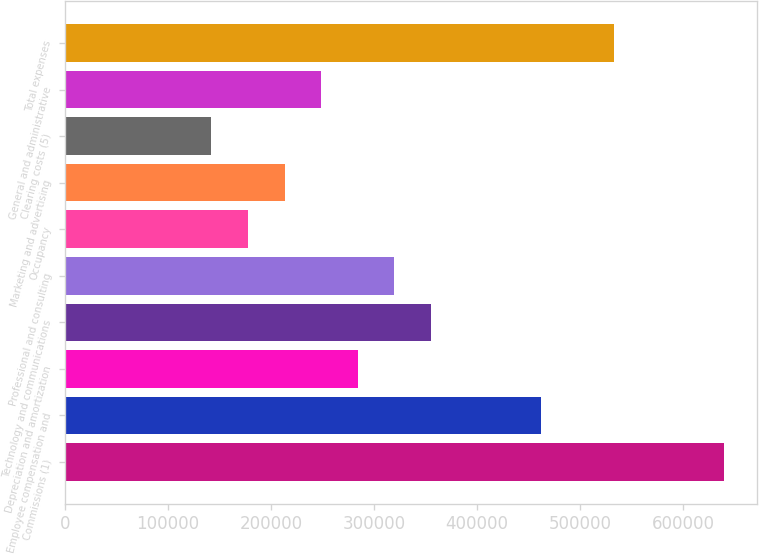Convert chart to OTSL. <chart><loc_0><loc_0><loc_500><loc_500><bar_chart><fcel>Commissions (1)<fcel>Employee compensation and<fcel>Depreciation and amortization<fcel>Technology and communications<fcel>Professional and consulting<fcel>Occupancy<fcel>Marketing and advertising<fcel>Clearing costs (5)<fcel>General and administrative<fcel>Total expenses<nl><fcel>639507<fcel>461866<fcel>284226<fcel>355282<fcel>319754<fcel>177642<fcel>213170<fcel>142114<fcel>248698<fcel>532922<nl></chart> 